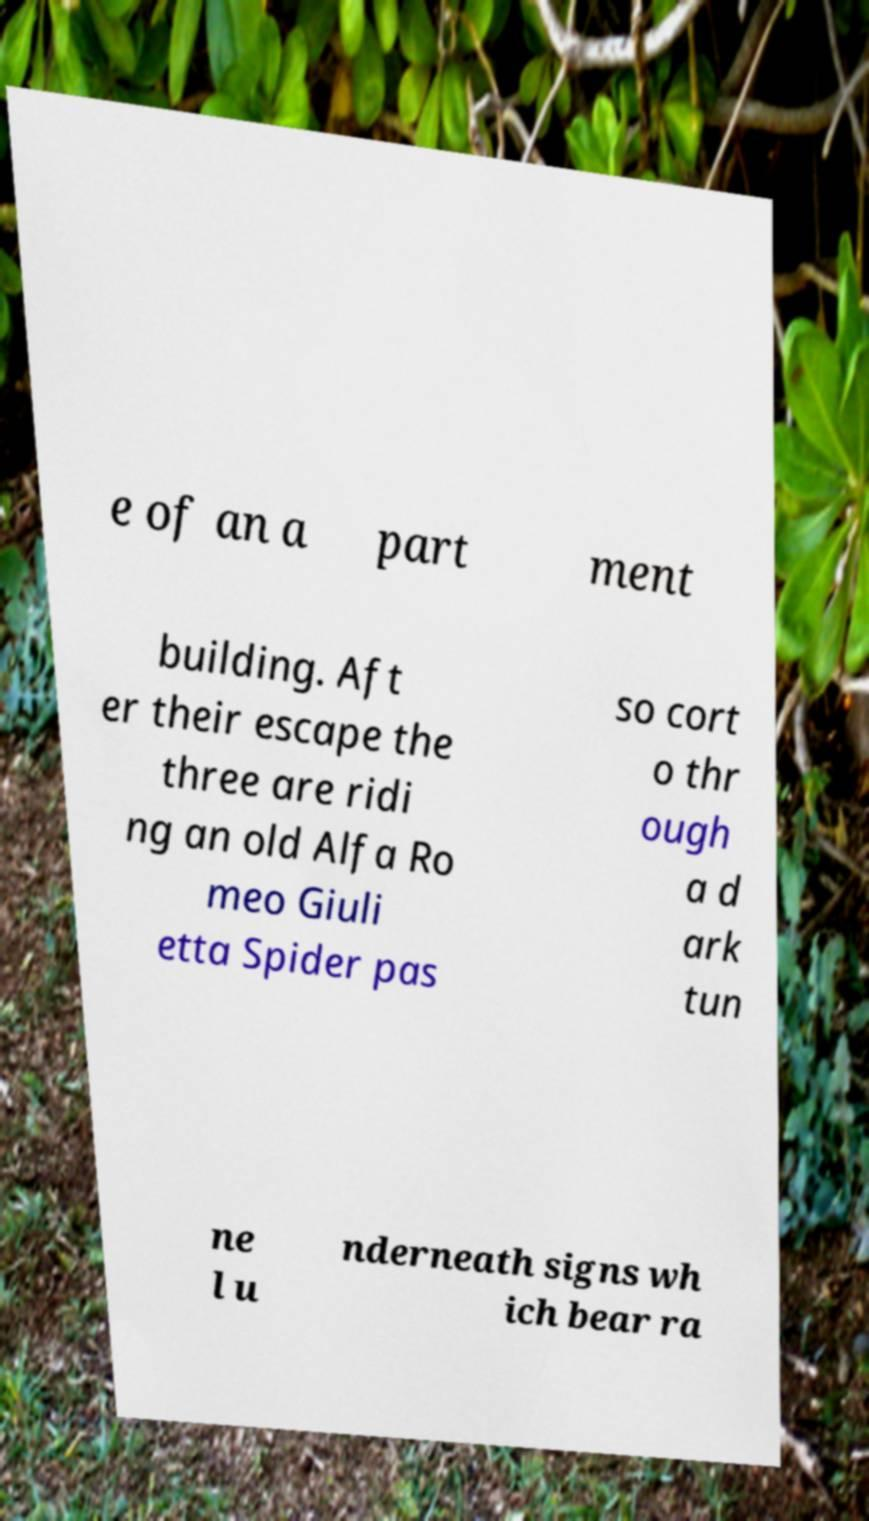Please identify and transcribe the text found in this image. e of an a part ment building. Aft er their escape the three are ridi ng an old Alfa Ro meo Giuli etta Spider pas so cort o thr ough a d ark tun ne l u nderneath signs wh ich bear ra 